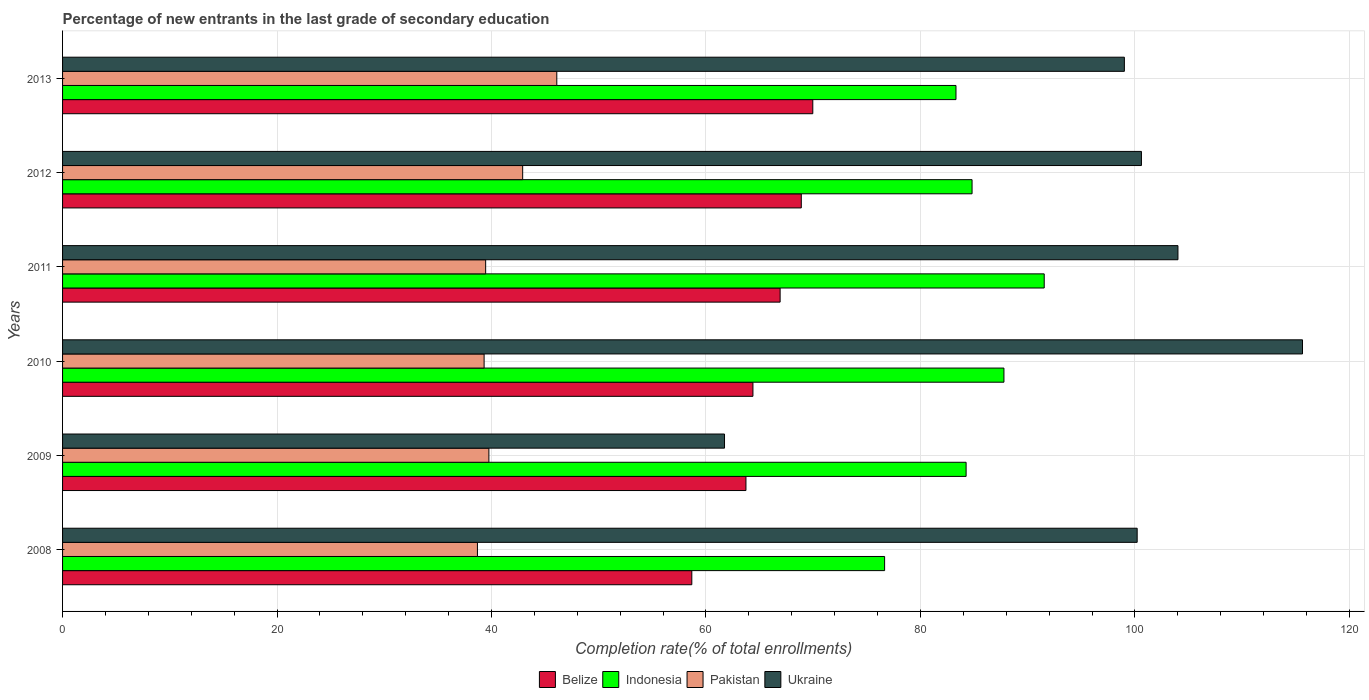How many different coloured bars are there?
Make the answer very short. 4. Are the number of bars per tick equal to the number of legend labels?
Give a very brief answer. Yes. How many bars are there on the 5th tick from the top?
Keep it short and to the point. 4. How many bars are there on the 4th tick from the bottom?
Offer a very short reply. 4. What is the label of the 3rd group of bars from the top?
Offer a very short reply. 2011. In how many cases, is the number of bars for a given year not equal to the number of legend labels?
Your answer should be compact. 0. What is the percentage of new entrants in Ukraine in 2009?
Provide a succinct answer. 61.73. Across all years, what is the maximum percentage of new entrants in Pakistan?
Offer a very short reply. 46.09. Across all years, what is the minimum percentage of new entrants in Ukraine?
Offer a very short reply. 61.73. In which year was the percentage of new entrants in Belize maximum?
Your answer should be very brief. 2013. What is the total percentage of new entrants in Pakistan in the graph?
Ensure brevity in your answer.  246.2. What is the difference between the percentage of new entrants in Pakistan in 2011 and that in 2012?
Make the answer very short. -3.45. What is the difference between the percentage of new entrants in Ukraine in 2010 and the percentage of new entrants in Pakistan in 2011?
Make the answer very short. 76.17. What is the average percentage of new entrants in Pakistan per year?
Provide a succinct answer. 41.03. In the year 2011, what is the difference between the percentage of new entrants in Belize and percentage of new entrants in Ukraine?
Give a very brief answer. -37.1. In how many years, is the percentage of new entrants in Ukraine greater than 68 %?
Make the answer very short. 5. What is the ratio of the percentage of new entrants in Ukraine in 2010 to that in 2013?
Make the answer very short. 1.17. What is the difference between the highest and the second highest percentage of new entrants in Indonesia?
Provide a short and direct response. 3.76. What is the difference between the highest and the lowest percentage of new entrants in Ukraine?
Provide a short and direct response. 53.9. Is it the case that in every year, the sum of the percentage of new entrants in Ukraine and percentage of new entrants in Indonesia is greater than the sum of percentage of new entrants in Pakistan and percentage of new entrants in Belize?
Give a very brief answer. No. What does the 4th bar from the top in 2011 represents?
Give a very brief answer. Belize. Is it the case that in every year, the sum of the percentage of new entrants in Pakistan and percentage of new entrants in Ukraine is greater than the percentage of new entrants in Belize?
Offer a very short reply. Yes. Are the values on the major ticks of X-axis written in scientific E-notation?
Provide a short and direct response. No. Does the graph contain any zero values?
Provide a short and direct response. No. Does the graph contain grids?
Give a very brief answer. Yes. What is the title of the graph?
Your response must be concise. Percentage of new entrants in the last grade of secondary education. What is the label or title of the X-axis?
Make the answer very short. Completion rate(% of total enrollments). What is the Completion rate(% of total enrollments) of Belize in 2008?
Your response must be concise. 58.68. What is the Completion rate(% of total enrollments) in Indonesia in 2008?
Ensure brevity in your answer.  76.66. What is the Completion rate(% of total enrollments) in Pakistan in 2008?
Give a very brief answer. 38.69. What is the Completion rate(% of total enrollments) in Ukraine in 2008?
Your response must be concise. 100.21. What is the Completion rate(% of total enrollments) in Belize in 2009?
Your response must be concise. 63.73. What is the Completion rate(% of total enrollments) of Indonesia in 2009?
Ensure brevity in your answer.  84.26. What is the Completion rate(% of total enrollments) of Pakistan in 2009?
Your answer should be very brief. 39.76. What is the Completion rate(% of total enrollments) of Ukraine in 2009?
Provide a succinct answer. 61.73. What is the Completion rate(% of total enrollments) of Belize in 2010?
Your answer should be very brief. 64.38. What is the Completion rate(% of total enrollments) of Indonesia in 2010?
Give a very brief answer. 87.79. What is the Completion rate(% of total enrollments) of Pakistan in 2010?
Give a very brief answer. 39.31. What is the Completion rate(% of total enrollments) in Ukraine in 2010?
Make the answer very short. 115.63. What is the Completion rate(% of total enrollments) in Belize in 2011?
Your answer should be compact. 66.91. What is the Completion rate(% of total enrollments) in Indonesia in 2011?
Your answer should be very brief. 91.54. What is the Completion rate(% of total enrollments) in Pakistan in 2011?
Your answer should be very brief. 39.45. What is the Completion rate(% of total enrollments) in Ukraine in 2011?
Your answer should be compact. 104.01. What is the Completion rate(% of total enrollments) in Belize in 2012?
Offer a terse response. 68.89. What is the Completion rate(% of total enrollments) of Indonesia in 2012?
Make the answer very short. 84.81. What is the Completion rate(% of total enrollments) in Pakistan in 2012?
Keep it short and to the point. 42.91. What is the Completion rate(% of total enrollments) in Ukraine in 2012?
Provide a short and direct response. 100.61. What is the Completion rate(% of total enrollments) in Belize in 2013?
Keep it short and to the point. 69.96. What is the Completion rate(% of total enrollments) of Indonesia in 2013?
Offer a very short reply. 83.31. What is the Completion rate(% of total enrollments) of Pakistan in 2013?
Provide a short and direct response. 46.09. What is the Completion rate(% of total enrollments) in Ukraine in 2013?
Your response must be concise. 99.02. Across all years, what is the maximum Completion rate(% of total enrollments) in Belize?
Offer a terse response. 69.96. Across all years, what is the maximum Completion rate(% of total enrollments) in Indonesia?
Offer a very short reply. 91.54. Across all years, what is the maximum Completion rate(% of total enrollments) of Pakistan?
Your answer should be compact. 46.09. Across all years, what is the maximum Completion rate(% of total enrollments) in Ukraine?
Offer a very short reply. 115.63. Across all years, what is the minimum Completion rate(% of total enrollments) in Belize?
Your answer should be very brief. 58.68. Across all years, what is the minimum Completion rate(% of total enrollments) of Indonesia?
Ensure brevity in your answer.  76.66. Across all years, what is the minimum Completion rate(% of total enrollments) in Pakistan?
Offer a terse response. 38.69. Across all years, what is the minimum Completion rate(% of total enrollments) of Ukraine?
Give a very brief answer. 61.73. What is the total Completion rate(% of total enrollments) of Belize in the graph?
Ensure brevity in your answer.  392.55. What is the total Completion rate(% of total enrollments) in Indonesia in the graph?
Keep it short and to the point. 508.37. What is the total Completion rate(% of total enrollments) of Pakistan in the graph?
Give a very brief answer. 246.2. What is the total Completion rate(% of total enrollments) in Ukraine in the graph?
Offer a very short reply. 581.21. What is the difference between the Completion rate(% of total enrollments) in Belize in 2008 and that in 2009?
Ensure brevity in your answer.  -5.05. What is the difference between the Completion rate(% of total enrollments) of Indonesia in 2008 and that in 2009?
Make the answer very short. -7.6. What is the difference between the Completion rate(% of total enrollments) of Pakistan in 2008 and that in 2009?
Keep it short and to the point. -1.07. What is the difference between the Completion rate(% of total enrollments) in Ukraine in 2008 and that in 2009?
Keep it short and to the point. 38.48. What is the difference between the Completion rate(% of total enrollments) in Belize in 2008 and that in 2010?
Give a very brief answer. -5.7. What is the difference between the Completion rate(% of total enrollments) of Indonesia in 2008 and that in 2010?
Offer a very short reply. -11.13. What is the difference between the Completion rate(% of total enrollments) of Pakistan in 2008 and that in 2010?
Ensure brevity in your answer.  -0.62. What is the difference between the Completion rate(% of total enrollments) in Ukraine in 2008 and that in 2010?
Make the answer very short. -15.42. What is the difference between the Completion rate(% of total enrollments) in Belize in 2008 and that in 2011?
Offer a very short reply. -8.23. What is the difference between the Completion rate(% of total enrollments) in Indonesia in 2008 and that in 2011?
Give a very brief answer. -14.88. What is the difference between the Completion rate(% of total enrollments) in Pakistan in 2008 and that in 2011?
Provide a succinct answer. -0.77. What is the difference between the Completion rate(% of total enrollments) of Ukraine in 2008 and that in 2011?
Make the answer very short. -3.8. What is the difference between the Completion rate(% of total enrollments) of Belize in 2008 and that in 2012?
Give a very brief answer. -10.21. What is the difference between the Completion rate(% of total enrollments) of Indonesia in 2008 and that in 2012?
Your answer should be compact. -8.16. What is the difference between the Completion rate(% of total enrollments) of Pakistan in 2008 and that in 2012?
Offer a very short reply. -4.22. What is the difference between the Completion rate(% of total enrollments) of Ukraine in 2008 and that in 2012?
Give a very brief answer. -0.4. What is the difference between the Completion rate(% of total enrollments) of Belize in 2008 and that in 2013?
Offer a very short reply. -11.28. What is the difference between the Completion rate(% of total enrollments) in Indonesia in 2008 and that in 2013?
Provide a succinct answer. -6.66. What is the difference between the Completion rate(% of total enrollments) in Pakistan in 2008 and that in 2013?
Give a very brief answer. -7.4. What is the difference between the Completion rate(% of total enrollments) in Ukraine in 2008 and that in 2013?
Your answer should be very brief. 1.19. What is the difference between the Completion rate(% of total enrollments) in Belize in 2009 and that in 2010?
Offer a very short reply. -0.65. What is the difference between the Completion rate(% of total enrollments) in Indonesia in 2009 and that in 2010?
Give a very brief answer. -3.53. What is the difference between the Completion rate(% of total enrollments) in Pakistan in 2009 and that in 2010?
Offer a very short reply. 0.45. What is the difference between the Completion rate(% of total enrollments) in Ukraine in 2009 and that in 2010?
Give a very brief answer. -53.9. What is the difference between the Completion rate(% of total enrollments) of Belize in 2009 and that in 2011?
Your answer should be very brief. -3.19. What is the difference between the Completion rate(% of total enrollments) of Indonesia in 2009 and that in 2011?
Ensure brevity in your answer.  -7.28. What is the difference between the Completion rate(% of total enrollments) in Pakistan in 2009 and that in 2011?
Offer a terse response. 0.3. What is the difference between the Completion rate(% of total enrollments) in Ukraine in 2009 and that in 2011?
Provide a succinct answer. -42.28. What is the difference between the Completion rate(% of total enrollments) of Belize in 2009 and that in 2012?
Give a very brief answer. -5.16. What is the difference between the Completion rate(% of total enrollments) in Indonesia in 2009 and that in 2012?
Your answer should be very brief. -0.56. What is the difference between the Completion rate(% of total enrollments) in Pakistan in 2009 and that in 2012?
Offer a terse response. -3.15. What is the difference between the Completion rate(% of total enrollments) of Ukraine in 2009 and that in 2012?
Keep it short and to the point. -38.88. What is the difference between the Completion rate(% of total enrollments) in Belize in 2009 and that in 2013?
Your answer should be very brief. -6.23. What is the difference between the Completion rate(% of total enrollments) of Indonesia in 2009 and that in 2013?
Your answer should be very brief. 0.94. What is the difference between the Completion rate(% of total enrollments) in Pakistan in 2009 and that in 2013?
Offer a very short reply. -6.33. What is the difference between the Completion rate(% of total enrollments) of Ukraine in 2009 and that in 2013?
Ensure brevity in your answer.  -37.29. What is the difference between the Completion rate(% of total enrollments) in Belize in 2010 and that in 2011?
Keep it short and to the point. -2.54. What is the difference between the Completion rate(% of total enrollments) of Indonesia in 2010 and that in 2011?
Offer a very short reply. -3.76. What is the difference between the Completion rate(% of total enrollments) of Pakistan in 2010 and that in 2011?
Make the answer very short. -0.14. What is the difference between the Completion rate(% of total enrollments) of Ukraine in 2010 and that in 2011?
Offer a terse response. 11.61. What is the difference between the Completion rate(% of total enrollments) of Belize in 2010 and that in 2012?
Make the answer very short. -4.51. What is the difference between the Completion rate(% of total enrollments) in Indonesia in 2010 and that in 2012?
Your response must be concise. 2.97. What is the difference between the Completion rate(% of total enrollments) in Pakistan in 2010 and that in 2012?
Provide a short and direct response. -3.6. What is the difference between the Completion rate(% of total enrollments) of Ukraine in 2010 and that in 2012?
Make the answer very short. 15.02. What is the difference between the Completion rate(% of total enrollments) in Belize in 2010 and that in 2013?
Your answer should be very brief. -5.58. What is the difference between the Completion rate(% of total enrollments) in Indonesia in 2010 and that in 2013?
Your answer should be very brief. 4.47. What is the difference between the Completion rate(% of total enrollments) of Pakistan in 2010 and that in 2013?
Keep it short and to the point. -6.78. What is the difference between the Completion rate(% of total enrollments) of Ukraine in 2010 and that in 2013?
Your response must be concise. 16.61. What is the difference between the Completion rate(% of total enrollments) of Belize in 2011 and that in 2012?
Your answer should be compact. -1.97. What is the difference between the Completion rate(% of total enrollments) in Indonesia in 2011 and that in 2012?
Your answer should be compact. 6.73. What is the difference between the Completion rate(% of total enrollments) in Pakistan in 2011 and that in 2012?
Give a very brief answer. -3.45. What is the difference between the Completion rate(% of total enrollments) of Ukraine in 2011 and that in 2012?
Make the answer very short. 3.4. What is the difference between the Completion rate(% of total enrollments) in Belize in 2011 and that in 2013?
Provide a succinct answer. -3.05. What is the difference between the Completion rate(% of total enrollments) in Indonesia in 2011 and that in 2013?
Your answer should be very brief. 8.23. What is the difference between the Completion rate(% of total enrollments) of Pakistan in 2011 and that in 2013?
Your answer should be very brief. -6.63. What is the difference between the Completion rate(% of total enrollments) of Ukraine in 2011 and that in 2013?
Provide a succinct answer. 5. What is the difference between the Completion rate(% of total enrollments) in Belize in 2012 and that in 2013?
Your answer should be very brief. -1.07. What is the difference between the Completion rate(% of total enrollments) of Indonesia in 2012 and that in 2013?
Make the answer very short. 1.5. What is the difference between the Completion rate(% of total enrollments) of Pakistan in 2012 and that in 2013?
Your answer should be very brief. -3.18. What is the difference between the Completion rate(% of total enrollments) in Ukraine in 2012 and that in 2013?
Offer a very short reply. 1.59. What is the difference between the Completion rate(% of total enrollments) in Belize in 2008 and the Completion rate(% of total enrollments) in Indonesia in 2009?
Your answer should be very brief. -25.58. What is the difference between the Completion rate(% of total enrollments) of Belize in 2008 and the Completion rate(% of total enrollments) of Pakistan in 2009?
Ensure brevity in your answer.  18.92. What is the difference between the Completion rate(% of total enrollments) in Belize in 2008 and the Completion rate(% of total enrollments) in Ukraine in 2009?
Your response must be concise. -3.05. What is the difference between the Completion rate(% of total enrollments) of Indonesia in 2008 and the Completion rate(% of total enrollments) of Pakistan in 2009?
Offer a very short reply. 36.9. What is the difference between the Completion rate(% of total enrollments) in Indonesia in 2008 and the Completion rate(% of total enrollments) in Ukraine in 2009?
Your answer should be very brief. 14.93. What is the difference between the Completion rate(% of total enrollments) of Pakistan in 2008 and the Completion rate(% of total enrollments) of Ukraine in 2009?
Offer a terse response. -23.04. What is the difference between the Completion rate(% of total enrollments) of Belize in 2008 and the Completion rate(% of total enrollments) of Indonesia in 2010?
Provide a short and direct response. -29.11. What is the difference between the Completion rate(% of total enrollments) in Belize in 2008 and the Completion rate(% of total enrollments) in Pakistan in 2010?
Offer a very short reply. 19.37. What is the difference between the Completion rate(% of total enrollments) in Belize in 2008 and the Completion rate(% of total enrollments) in Ukraine in 2010?
Give a very brief answer. -56.95. What is the difference between the Completion rate(% of total enrollments) of Indonesia in 2008 and the Completion rate(% of total enrollments) of Pakistan in 2010?
Make the answer very short. 37.35. What is the difference between the Completion rate(% of total enrollments) of Indonesia in 2008 and the Completion rate(% of total enrollments) of Ukraine in 2010?
Offer a very short reply. -38.97. What is the difference between the Completion rate(% of total enrollments) of Pakistan in 2008 and the Completion rate(% of total enrollments) of Ukraine in 2010?
Your response must be concise. -76.94. What is the difference between the Completion rate(% of total enrollments) of Belize in 2008 and the Completion rate(% of total enrollments) of Indonesia in 2011?
Provide a short and direct response. -32.86. What is the difference between the Completion rate(% of total enrollments) in Belize in 2008 and the Completion rate(% of total enrollments) in Pakistan in 2011?
Your answer should be very brief. 19.23. What is the difference between the Completion rate(% of total enrollments) of Belize in 2008 and the Completion rate(% of total enrollments) of Ukraine in 2011?
Provide a succinct answer. -45.33. What is the difference between the Completion rate(% of total enrollments) of Indonesia in 2008 and the Completion rate(% of total enrollments) of Pakistan in 2011?
Your response must be concise. 37.2. What is the difference between the Completion rate(% of total enrollments) of Indonesia in 2008 and the Completion rate(% of total enrollments) of Ukraine in 2011?
Ensure brevity in your answer.  -27.36. What is the difference between the Completion rate(% of total enrollments) in Pakistan in 2008 and the Completion rate(% of total enrollments) in Ukraine in 2011?
Offer a very short reply. -65.33. What is the difference between the Completion rate(% of total enrollments) in Belize in 2008 and the Completion rate(% of total enrollments) in Indonesia in 2012?
Offer a terse response. -26.13. What is the difference between the Completion rate(% of total enrollments) in Belize in 2008 and the Completion rate(% of total enrollments) in Pakistan in 2012?
Provide a short and direct response. 15.77. What is the difference between the Completion rate(% of total enrollments) of Belize in 2008 and the Completion rate(% of total enrollments) of Ukraine in 2012?
Make the answer very short. -41.93. What is the difference between the Completion rate(% of total enrollments) of Indonesia in 2008 and the Completion rate(% of total enrollments) of Pakistan in 2012?
Give a very brief answer. 33.75. What is the difference between the Completion rate(% of total enrollments) in Indonesia in 2008 and the Completion rate(% of total enrollments) in Ukraine in 2012?
Give a very brief answer. -23.95. What is the difference between the Completion rate(% of total enrollments) of Pakistan in 2008 and the Completion rate(% of total enrollments) of Ukraine in 2012?
Your response must be concise. -61.92. What is the difference between the Completion rate(% of total enrollments) in Belize in 2008 and the Completion rate(% of total enrollments) in Indonesia in 2013?
Provide a succinct answer. -24.64. What is the difference between the Completion rate(% of total enrollments) in Belize in 2008 and the Completion rate(% of total enrollments) in Pakistan in 2013?
Ensure brevity in your answer.  12.59. What is the difference between the Completion rate(% of total enrollments) in Belize in 2008 and the Completion rate(% of total enrollments) in Ukraine in 2013?
Make the answer very short. -40.34. What is the difference between the Completion rate(% of total enrollments) in Indonesia in 2008 and the Completion rate(% of total enrollments) in Pakistan in 2013?
Make the answer very short. 30.57. What is the difference between the Completion rate(% of total enrollments) in Indonesia in 2008 and the Completion rate(% of total enrollments) in Ukraine in 2013?
Provide a succinct answer. -22.36. What is the difference between the Completion rate(% of total enrollments) of Pakistan in 2008 and the Completion rate(% of total enrollments) of Ukraine in 2013?
Your answer should be very brief. -60.33. What is the difference between the Completion rate(% of total enrollments) in Belize in 2009 and the Completion rate(% of total enrollments) in Indonesia in 2010?
Your answer should be compact. -24.06. What is the difference between the Completion rate(% of total enrollments) of Belize in 2009 and the Completion rate(% of total enrollments) of Pakistan in 2010?
Your answer should be compact. 24.42. What is the difference between the Completion rate(% of total enrollments) of Belize in 2009 and the Completion rate(% of total enrollments) of Ukraine in 2010?
Provide a succinct answer. -51.9. What is the difference between the Completion rate(% of total enrollments) in Indonesia in 2009 and the Completion rate(% of total enrollments) in Pakistan in 2010?
Give a very brief answer. 44.95. What is the difference between the Completion rate(% of total enrollments) in Indonesia in 2009 and the Completion rate(% of total enrollments) in Ukraine in 2010?
Your answer should be compact. -31.37. What is the difference between the Completion rate(% of total enrollments) in Pakistan in 2009 and the Completion rate(% of total enrollments) in Ukraine in 2010?
Your answer should be compact. -75.87. What is the difference between the Completion rate(% of total enrollments) in Belize in 2009 and the Completion rate(% of total enrollments) in Indonesia in 2011?
Provide a short and direct response. -27.82. What is the difference between the Completion rate(% of total enrollments) in Belize in 2009 and the Completion rate(% of total enrollments) in Pakistan in 2011?
Offer a terse response. 24.27. What is the difference between the Completion rate(% of total enrollments) of Belize in 2009 and the Completion rate(% of total enrollments) of Ukraine in 2011?
Your response must be concise. -40.29. What is the difference between the Completion rate(% of total enrollments) of Indonesia in 2009 and the Completion rate(% of total enrollments) of Pakistan in 2011?
Offer a terse response. 44.8. What is the difference between the Completion rate(% of total enrollments) of Indonesia in 2009 and the Completion rate(% of total enrollments) of Ukraine in 2011?
Offer a terse response. -19.75. What is the difference between the Completion rate(% of total enrollments) of Pakistan in 2009 and the Completion rate(% of total enrollments) of Ukraine in 2011?
Offer a very short reply. -64.26. What is the difference between the Completion rate(% of total enrollments) in Belize in 2009 and the Completion rate(% of total enrollments) in Indonesia in 2012?
Your answer should be compact. -21.09. What is the difference between the Completion rate(% of total enrollments) of Belize in 2009 and the Completion rate(% of total enrollments) of Pakistan in 2012?
Provide a succinct answer. 20.82. What is the difference between the Completion rate(% of total enrollments) of Belize in 2009 and the Completion rate(% of total enrollments) of Ukraine in 2012?
Ensure brevity in your answer.  -36.88. What is the difference between the Completion rate(% of total enrollments) in Indonesia in 2009 and the Completion rate(% of total enrollments) in Pakistan in 2012?
Offer a very short reply. 41.35. What is the difference between the Completion rate(% of total enrollments) in Indonesia in 2009 and the Completion rate(% of total enrollments) in Ukraine in 2012?
Give a very brief answer. -16.35. What is the difference between the Completion rate(% of total enrollments) in Pakistan in 2009 and the Completion rate(% of total enrollments) in Ukraine in 2012?
Offer a very short reply. -60.85. What is the difference between the Completion rate(% of total enrollments) in Belize in 2009 and the Completion rate(% of total enrollments) in Indonesia in 2013?
Offer a very short reply. -19.59. What is the difference between the Completion rate(% of total enrollments) of Belize in 2009 and the Completion rate(% of total enrollments) of Pakistan in 2013?
Offer a very short reply. 17.64. What is the difference between the Completion rate(% of total enrollments) in Belize in 2009 and the Completion rate(% of total enrollments) in Ukraine in 2013?
Your answer should be very brief. -35.29. What is the difference between the Completion rate(% of total enrollments) of Indonesia in 2009 and the Completion rate(% of total enrollments) of Pakistan in 2013?
Provide a short and direct response. 38.17. What is the difference between the Completion rate(% of total enrollments) in Indonesia in 2009 and the Completion rate(% of total enrollments) in Ukraine in 2013?
Give a very brief answer. -14.76. What is the difference between the Completion rate(% of total enrollments) of Pakistan in 2009 and the Completion rate(% of total enrollments) of Ukraine in 2013?
Your answer should be compact. -59.26. What is the difference between the Completion rate(% of total enrollments) of Belize in 2010 and the Completion rate(% of total enrollments) of Indonesia in 2011?
Provide a succinct answer. -27.16. What is the difference between the Completion rate(% of total enrollments) in Belize in 2010 and the Completion rate(% of total enrollments) in Pakistan in 2011?
Offer a very short reply. 24.92. What is the difference between the Completion rate(% of total enrollments) of Belize in 2010 and the Completion rate(% of total enrollments) of Ukraine in 2011?
Offer a very short reply. -39.63. What is the difference between the Completion rate(% of total enrollments) in Indonesia in 2010 and the Completion rate(% of total enrollments) in Pakistan in 2011?
Provide a short and direct response. 48.33. What is the difference between the Completion rate(% of total enrollments) of Indonesia in 2010 and the Completion rate(% of total enrollments) of Ukraine in 2011?
Your answer should be very brief. -16.23. What is the difference between the Completion rate(% of total enrollments) of Pakistan in 2010 and the Completion rate(% of total enrollments) of Ukraine in 2011?
Give a very brief answer. -64.7. What is the difference between the Completion rate(% of total enrollments) of Belize in 2010 and the Completion rate(% of total enrollments) of Indonesia in 2012?
Provide a short and direct response. -20.43. What is the difference between the Completion rate(% of total enrollments) of Belize in 2010 and the Completion rate(% of total enrollments) of Pakistan in 2012?
Your answer should be compact. 21.47. What is the difference between the Completion rate(% of total enrollments) of Belize in 2010 and the Completion rate(% of total enrollments) of Ukraine in 2012?
Make the answer very short. -36.23. What is the difference between the Completion rate(% of total enrollments) of Indonesia in 2010 and the Completion rate(% of total enrollments) of Pakistan in 2012?
Provide a short and direct response. 44.88. What is the difference between the Completion rate(% of total enrollments) in Indonesia in 2010 and the Completion rate(% of total enrollments) in Ukraine in 2012?
Offer a terse response. -12.82. What is the difference between the Completion rate(% of total enrollments) in Pakistan in 2010 and the Completion rate(% of total enrollments) in Ukraine in 2012?
Your response must be concise. -61.3. What is the difference between the Completion rate(% of total enrollments) of Belize in 2010 and the Completion rate(% of total enrollments) of Indonesia in 2013?
Give a very brief answer. -18.94. What is the difference between the Completion rate(% of total enrollments) of Belize in 2010 and the Completion rate(% of total enrollments) of Pakistan in 2013?
Provide a succinct answer. 18.29. What is the difference between the Completion rate(% of total enrollments) in Belize in 2010 and the Completion rate(% of total enrollments) in Ukraine in 2013?
Make the answer very short. -34.64. What is the difference between the Completion rate(% of total enrollments) of Indonesia in 2010 and the Completion rate(% of total enrollments) of Pakistan in 2013?
Offer a very short reply. 41.7. What is the difference between the Completion rate(% of total enrollments) of Indonesia in 2010 and the Completion rate(% of total enrollments) of Ukraine in 2013?
Keep it short and to the point. -11.23. What is the difference between the Completion rate(% of total enrollments) of Pakistan in 2010 and the Completion rate(% of total enrollments) of Ukraine in 2013?
Make the answer very short. -59.71. What is the difference between the Completion rate(% of total enrollments) of Belize in 2011 and the Completion rate(% of total enrollments) of Indonesia in 2012?
Your answer should be very brief. -17.9. What is the difference between the Completion rate(% of total enrollments) in Belize in 2011 and the Completion rate(% of total enrollments) in Pakistan in 2012?
Make the answer very short. 24.01. What is the difference between the Completion rate(% of total enrollments) in Belize in 2011 and the Completion rate(% of total enrollments) in Ukraine in 2012?
Keep it short and to the point. -33.69. What is the difference between the Completion rate(% of total enrollments) in Indonesia in 2011 and the Completion rate(% of total enrollments) in Pakistan in 2012?
Offer a terse response. 48.64. What is the difference between the Completion rate(% of total enrollments) of Indonesia in 2011 and the Completion rate(% of total enrollments) of Ukraine in 2012?
Offer a terse response. -9.07. What is the difference between the Completion rate(% of total enrollments) in Pakistan in 2011 and the Completion rate(% of total enrollments) in Ukraine in 2012?
Provide a short and direct response. -61.15. What is the difference between the Completion rate(% of total enrollments) in Belize in 2011 and the Completion rate(% of total enrollments) in Indonesia in 2013?
Keep it short and to the point. -16.4. What is the difference between the Completion rate(% of total enrollments) of Belize in 2011 and the Completion rate(% of total enrollments) of Pakistan in 2013?
Ensure brevity in your answer.  20.83. What is the difference between the Completion rate(% of total enrollments) in Belize in 2011 and the Completion rate(% of total enrollments) in Ukraine in 2013?
Ensure brevity in your answer.  -32.1. What is the difference between the Completion rate(% of total enrollments) of Indonesia in 2011 and the Completion rate(% of total enrollments) of Pakistan in 2013?
Provide a succinct answer. 45.45. What is the difference between the Completion rate(% of total enrollments) in Indonesia in 2011 and the Completion rate(% of total enrollments) in Ukraine in 2013?
Give a very brief answer. -7.47. What is the difference between the Completion rate(% of total enrollments) in Pakistan in 2011 and the Completion rate(% of total enrollments) in Ukraine in 2013?
Offer a very short reply. -59.56. What is the difference between the Completion rate(% of total enrollments) in Belize in 2012 and the Completion rate(% of total enrollments) in Indonesia in 2013?
Offer a very short reply. -14.43. What is the difference between the Completion rate(% of total enrollments) in Belize in 2012 and the Completion rate(% of total enrollments) in Pakistan in 2013?
Give a very brief answer. 22.8. What is the difference between the Completion rate(% of total enrollments) in Belize in 2012 and the Completion rate(% of total enrollments) in Ukraine in 2013?
Your answer should be compact. -30.13. What is the difference between the Completion rate(% of total enrollments) in Indonesia in 2012 and the Completion rate(% of total enrollments) in Pakistan in 2013?
Ensure brevity in your answer.  38.73. What is the difference between the Completion rate(% of total enrollments) of Indonesia in 2012 and the Completion rate(% of total enrollments) of Ukraine in 2013?
Make the answer very short. -14.2. What is the difference between the Completion rate(% of total enrollments) in Pakistan in 2012 and the Completion rate(% of total enrollments) in Ukraine in 2013?
Provide a short and direct response. -56.11. What is the average Completion rate(% of total enrollments) of Belize per year?
Your response must be concise. 65.43. What is the average Completion rate(% of total enrollments) of Indonesia per year?
Make the answer very short. 84.73. What is the average Completion rate(% of total enrollments) in Pakistan per year?
Ensure brevity in your answer.  41.03. What is the average Completion rate(% of total enrollments) in Ukraine per year?
Offer a terse response. 96.87. In the year 2008, what is the difference between the Completion rate(% of total enrollments) of Belize and Completion rate(% of total enrollments) of Indonesia?
Ensure brevity in your answer.  -17.98. In the year 2008, what is the difference between the Completion rate(% of total enrollments) of Belize and Completion rate(% of total enrollments) of Pakistan?
Keep it short and to the point. 19.99. In the year 2008, what is the difference between the Completion rate(% of total enrollments) in Belize and Completion rate(% of total enrollments) in Ukraine?
Provide a succinct answer. -41.53. In the year 2008, what is the difference between the Completion rate(% of total enrollments) of Indonesia and Completion rate(% of total enrollments) of Pakistan?
Keep it short and to the point. 37.97. In the year 2008, what is the difference between the Completion rate(% of total enrollments) of Indonesia and Completion rate(% of total enrollments) of Ukraine?
Your answer should be compact. -23.55. In the year 2008, what is the difference between the Completion rate(% of total enrollments) of Pakistan and Completion rate(% of total enrollments) of Ukraine?
Provide a short and direct response. -61.52. In the year 2009, what is the difference between the Completion rate(% of total enrollments) of Belize and Completion rate(% of total enrollments) of Indonesia?
Keep it short and to the point. -20.53. In the year 2009, what is the difference between the Completion rate(% of total enrollments) of Belize and Completion rate(% of total enrollments) of Pakistan?
Provide a succinct answer. 23.97. In the year 2009, what is the difference between the Completion rate(% of total enrollments) of Belize and Completion rate(% of total enrollments) of Ukraine?
Provide a succinct answer. 2. In the year 2009, what is the difference between the Completion rate(% of total enrollments) in Indonesia and Completion rate(% of total enrollments) in Pakistan?
Give a very brief answer. 44.5. In the year 2009, what is the difference between the Completion rate(% of total enrollments) of Indonesia and Completion rate(% of total enrollments) of Ukraine?
Your answer should be very brief. 22.53. In the year 2009, what is the difference between the Completion rate(% of total enrollments) in Pakistan and Completion rate(% of total enrollments) in Ukraine?
Offer a terse response. -21.97. In the year 2010, what is the difference between the Completion rate(% of total enrollments) in Belize and Completion rate(% of total enrollments) in Indonesia?
Keep it short and to the point. -23.41. In the year 2010, what is the difference between the Completion rate(% of total enrollments) of Belize and Completion rate(% of total enrollments) of Pakistan?
Give a very brief answer. 25.07. In the year 2010, what is the difference between the Completion rate(% of total enrollments) of Belize and Completion rate(% of total enrollments) of Ukraine?
Provide a short and direct response. -51.25. In the year 2010, what is the difference between the Completion rate(% of total enrollments) in Indonesia and Completion rate(% of total enrollments) in Pakistan?
Ensure brevity in your answer.  48.48. In the year 2010, what is the difference between the Completion rate(% of total enrollments) in Indonesia and Completion rate(% of total enrollments) in Ukraine?
Make the answer very short. -27.84. In the year 2010, what is the difference between the Completion rate(% of total enrollments) in Pakistan and Completion rate(% of total enrollments) in Ukraine?
Your answer should be compact. -76.32. In the year 2011, what is the difference between the Completion rate(% of total enrollments) in Belize and Completion rate(% of total enrollments) in Indonesia?
Your response must be concise. -24.63. In the year 2011, what is the difference between the Completion rate(% of total enrollments) in Belize and Completion rate(% of total enrollments) in Pakistan?
Your response must be concise. 27.46. In the year 2011, what is the difference between the Completion rate(% of total enrollments) in Belize and Completion rate(% of total enrollments) in Ukraine?
Provide a succinct answer. -37.1. In the year 2011, what is the difference between the Completion rate(% of total enrollments) in Indonesia and Completion rate(% of total enrollments) in Pakistan?
Keep it short and to the point. 52.09. In the year 2011, what is the difference between the Completion rate(% of total enrollments) in Indonesia and Completion rate(% of total enrollments) in Ukraine?
Offer a very short reply. -12.47. In the year 2011, what is the difference between the Completion rate(% of total enrollments) of Pakistan and Completion rate(% of total enrollments) of Ukraine?
Offer a very short reply. -64.56. In the year 2012, what is the difference between the Completion rate(% of total enrollments) in Belize and Completion rate(% of total enrollments) in Indonesia?
Provide a succinct answer. -15.93. In the year 2012, what is the difference between the Completion rate(% of total enrollments) of Belize and Completion rate(% of total enrollments) of Pakistan?
Ensure brevity in your answer.  25.98. In the year 2012, what is the difference between the Completion rate(% of total enrollments) in Belize and Completion rate(% of total enrollments) in Ukraine?
Give a very brief answer. -31.72. In the year 2012, what is the difference between the Completion rate(% of total enrollments) of Indonesia and Completion rate(% of total enrollments) of Pakistan?
Your response must be concise. 41.91. In the year 2012, what is the difference between the Completion rate(% of total enrollments) in Indonesia and Completion rate(% of total enrollments) in Ukraine?
Keep it short and to the point. -15.79. In the year 2012, what is the difference between the Completion rate(% of total enrollments) of Pakistan and Completion rate(% of total enrollments) of Ukraine?
Offer a very short reply. -57.7. In the year 2013, what is the difference between the Completion rate(% of total enrollments) in Belize and Completion rate(% of total enrollments) in Indonesia?
Give a very brief answer. -13.35. In the year 2013, what is the difference between the Completion rate(% of total enrollments) of Belize and Completion rate(% of total enrollments) of Pakistan?
Offer a very short reply. 23.87. In the year 2013, what is the difference between the Completion rate(% of total enrollments) in Belize and Completion rate(% of total enrollments) in Ukraine?
Keep it short and to the point. -29.05. In the year 2013, what is the difference between the Completion rate(% of total enrollments) of Indonesia and Completion rate(% of total enrollments) of Pakistan?
Your answer should be very brief. 37.23. In the year 2013, what is the difference between the Completion rate(% of total enrollments) in Indonesia and Completion rate(% of total enrollments) in Ukraine?
Your answer should be compact. -15.7. In the year 2013, what is the difference between the Completion rate(% of total enrollments) in Pakistan and Completion rate(% of total enrollments) in Ukraine?
Offer a very short reply. -52.93. What is the ratio of the Completion rate(% of total enrollments) of Belize in 2008 to that in 2009?
Your answer should be compact. 0.92. What is the ratio of the Completion rate(% of total enrollments) of Indonesia in 2008 to that in 2009?
Make the answer very short. 0.91. What is the ratio of the Completion rate(% of total enrollments) of Pakistan in 2008 to that in 2009?
Your response must be concise. 0.97. What is the ratio of the Completion rate(% of total enrollments) of Ukraine in 2008 to that in 2009?
Keep it short and to the point. 1.62. What is the ratio of the Completion rate(% of total enrollments) of Belize in 2008 to that in 2010?
Your answer should be compact. 0.91. What is the ratio of the Completion rate(% of total enrollments) in Indonesia in 2008 to that in 2010?
Offer a very short reply. 0.87. What is the ratio of the Completion rate(% of total enrollments) in Pakistan in 2008 to that in 2010?
Your answer should be compact. 0.98. What is the ratio of the Completion rate(% of total enrollments) of Ukraine in 2008 to that in 2010?
Keep it short and to the point. 0.87. What is the ratio of the Completion rate(% of total enrollments) in Belize in 2008 to that in 2011?
Offer a very short reply. 0.88. What is the ratio of the Completion rate(% of total enrollments) in Indonesia in 2008 to that in 2011?
Offer a terse response. 0.84. What is the ratio of the Completion rate(% of total enrollments) in Pakistan in 2008 to that in 2011?
Your answer should be very brief. 0.98. What is the ratio of the Completion rate(% of total enrollments) of Ukraine in 2008 to that in 2011?
Your answer should be very brief. 0.96. What is the ratio of the Completion rate(% of total enrollments) in Belize in 2008 to that in 2012?
Make the answer very short. 0.85. What is the ratio of the Completion rate(% of total enrollments) in Indonesia in 2008 to that in 2012?
Keep it short and to the point. 0.9. What is the ratio of the Completion rate(% of total enrollments) of Pakistan in 2008 to that in 2012?
Offer a terse response. 0.9. What is the ratio of the Completion rate(% of total enrollments) of Ukraine in 2008 to that in 2012?
Make the answer very short. 1. What is the ratio of the Completion rate(% of total enrollments) in Belize in 2008 to that in 2013?
Offer a terse response. 0.84. What is the ratio of the Completion rate(% of total enrollments) of Indonesia in 2008 to that in 2013?
Offer a very short reply. 0.92. What is the ratio of the Completion rate(% of total enrollments) of Pakistan in 2008 to that in 2013?
Your answer should be very brief. 0.84. What is the ratio of the Completion rate(% of total enrollments) of Ukraine in 2008 to that in 2013?
Provide a succinct answer. 1.01. What is the ratio of the Completion rate(% of total enrollments) of Indonesia in 2009 to that in 2010?
Make the answer very short. 0.96. What is the ratio of the Completion rate(% of total enrollments) of Pakistan in 2009 to that in 2010?
Offer a terse response. 1.01. What is the ratio of the Completion rate(% of total enrollments) in Ukraine in 2009 to that in 2010?
Give a very brief answer. 0.53. What is the ratio of the Completion rate(% of total enrollments) of Indonesia in 2009 to that in 2011?
Your response must be concise. 0.92. What is the ratio of the Completion rate(% of total enrollments) in Pakistan in 2009 to that in 2011?
Offer a terse response. 1.01. What is the ratio of the Completion rate(% of total enrollments) in Ukraine in 2009 to that in 2011?
Give a very brief answer. 0.59. What is the ratio of the Completion rate(% of total enrollments) in Belize in 2009 to that in 2012?
Your answer should be compact. 0.93. What is the ratio of the Completion rate(% of total enrollments) of Pakistan in 2009 to that in 2012?
Offer a very short reply. 0.93. What is the ratio of the Completion rate(% of total enrollments) in Ukraine in 2009 to that in 2012?
Ensure brevity in your answer.  0.61. What is the ratio of the Completion rate(% of total enrollments) of Belize in 2009 to that in 2013?
Your response must be concise. 0.91. What is the ratio of the Completion rate(% of total enrollments) of Indonesia in 2009 to that in 2013?
Your answer should be compact. 1.01. What is the ratio of the Completion rate(% of total enrollments) of Pakistan in 2009 to that in 2013?
Your answer should be compact. 0.86. What is the ratio of the Completion rate(% of total enrollments) of Ukraine in 2009 to that in 2013?
Ensure brevity in your answer.  0.62. What is the ratio of the Completion rate(% of total enrollments) of Belize in 2010 to that in 2011?
Provide a succinct answer. 0.96. What is the ratio of the Completion rate(% of total enrollments) of Indonesia in 2010 to that in 2011?
Provide a short and direct response. 0.96. What is the ratio of the Completion rate(% of total enrollments) of Ukraine in 2010 to that in 2011?
Ensure brevity in your answer.  1.11. What is the ratio of the Completion rate(% of total enrollments) of Belize in 2010 to that in 2012?
Offer a terse response. 0.93. What is the ratio of the Completion rate(% of total enrollments) of Indonesia in 2010 to that in 2012?
Your response must be concise. 1.03. What is the ratio of the Completion rate(% of total enrollments) of Pakistan in 2010 to that in 2012?
Your answer should be compact. 0.92. What is the ratio of the Completion rate(% of total enrollments) of Ukraine in 2010 to that in 2012?
Provide a short and direct response. 1.15. What is the ratio of the Completion rate(% of total enrollments) in Belize in 2010 to that in 2013?
Offer a very short reply. 0.92. What is the ratio of the Completion rate(% of total enrollments) in Indonesia in 2010 to that in 2013?
Offer a terse response. 1.05. What is the ratio of the Completion rate(% of total enrollments) in Pakistan in 2010 to that in 2013?
Make the answer very short. 0.85. What is the ratio of the Completion rate(% of total enrollments) of Ukraine in 2010 to that in 2013?
Provide a short and direct response. 1.17. What is the ratio of the Completion rate(% of total enrollments) of Belize in 2011 to that in 2012?
Make the answer very short. 0.97. What is the ratio of the Completion rate(% of total enrollments) in Indonesia in 2011 to that in 2012?
Ensure brevity in your answer.  1.08. What is the ratio of the Completion rate(% of total enrollments) in Pakistan in 2011 to that in 2012?
Provide a succinct answer. 0.92. What is the ratio of the Completion rate(% of total enrollments) in Ukraine in 2011 to that in 2012?
Keep it short and to the point. 1.03. What is the ratio of the Completion rate(% of total enrollments) of Belize in 2011 to that in 2013?
Provide a short and direct response. 0.96. What is the ratio of the Completion rate(% of total enrollments) of Indonesia in 2011 to that in 2013?
Offer a very short reply. 1.1. What is the ratio of the Completion rate(% of total enrollments) in Pakistan in 2011 to that in 2013?
Your answer should be very brief. 0.86. What is the ratio of the Completion rate(% of total enrollments) in Ukraine in 2011 to that in 2013?
Your answer should be compact. 1.05. What is the ratio of the Completion rate(% of total enrollments) of Belize in 2012 to that in 2013?
Make the answer very short. 0.98. What is the ratio of the Completion rate(% of total enrollments) in Ukraine in 2012 to that in 2013?
Give a very brief answer. 1.02. What is the difference between the highest and the second highest Completion rate(% of total enrollments) of Belize?
Keep it short and to the point. 1.07. What is the difference between the highest and the second highest Completion rate(% of total enrollments) of Indonesia?
Provide a short and direct response. 3.76. What is the difference between the highest and the second highest Completion rate(% of total enrollments) of Pakistan?
Ensure brevity in your answer.  3.18. What is the difference between the highest and the second highest Completion rate(% of total enrollments) of Ukraine?
Offer a terse response. 11.61. What is the difference between the highest and the lowest Completion rate(% of total enrollments) of Belize?
Ensure brevity in your answer.  11.28. What is the difference between the highest and the lowest Completion rate(% of total enrollments) in Indonesia?
Ensure brevity in your answer.  14.88. What is the difference between the highest and the lowest Completion rate(% of total enrollments) of Pakistan?
Provide a short and direct response. 7.4. What is the difference between the highest and the lowest Completion rate(% of total enrollments) of Ukraine?
Give a very brief answer. 53.9. 